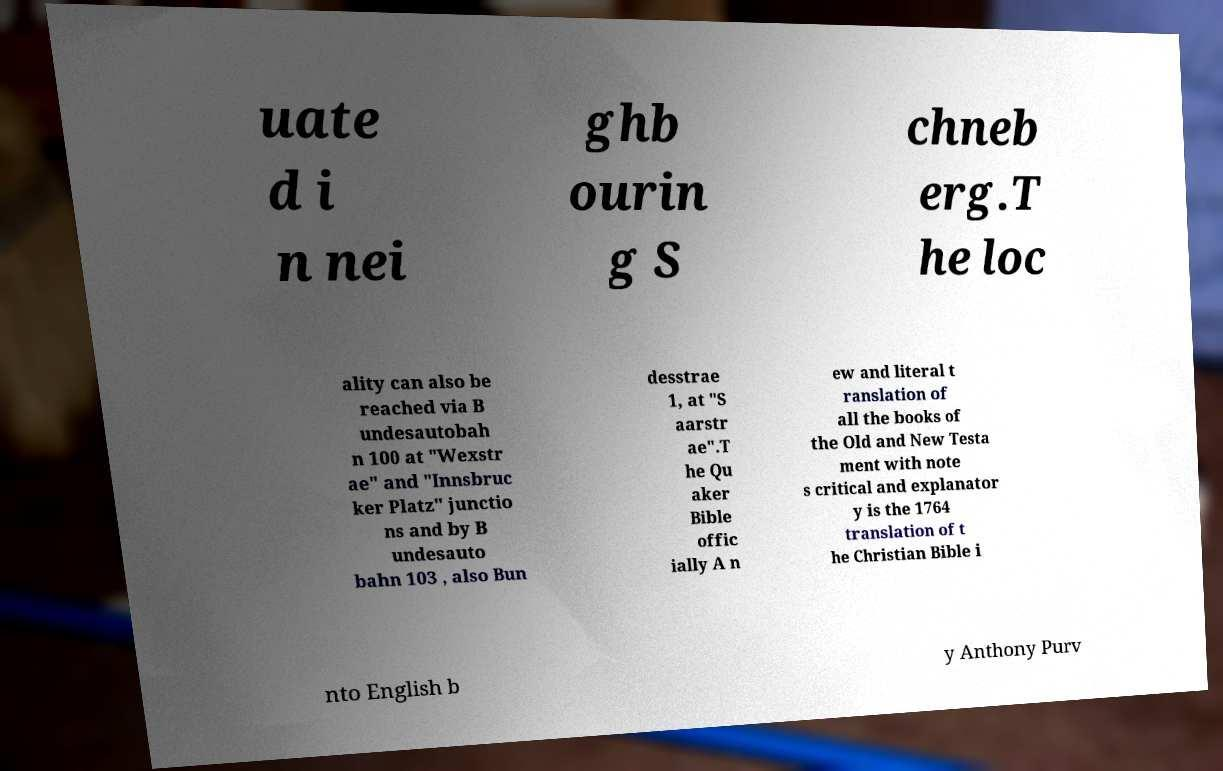For documentation purposes, I need the text within this image transcribed. Could you provide that? uate d i n nei ghb ourin g S chneb erg.T he loc ality can also be reached via B undesautobah n 100 at "Wexstr ae" and "Innsbruc ker Platz" junctio ns and by B undesauto bahn 103 , also Bun desstrae 1, at "S aarstr ae".T he Qu aker Bible offic ially A n ew and literal t ranslation of all the books of the Old and New Testa ment with note s critical and explanator y is the 1764 translation of t he Christian Bible i nto English b y Anthony Purv 